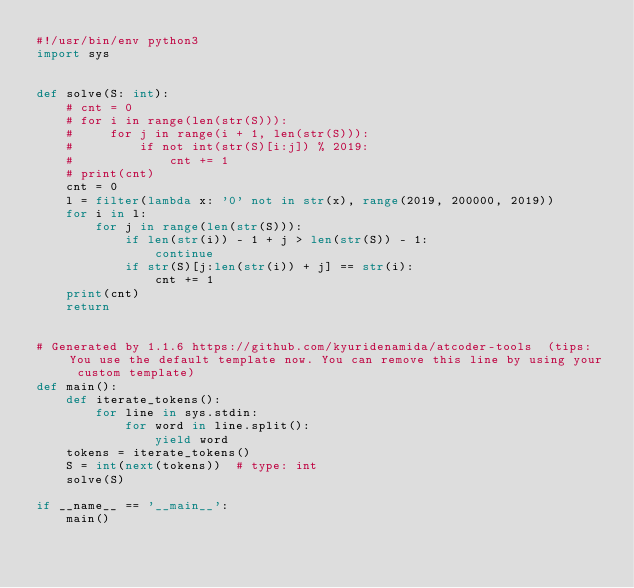Convert code to text. <code><loc_0><loc_0><loc_500><loc_500><_Python_>#!/usr/bin/env python3
import sys
 
 
def solve(S: int):
    # cnt = 0
    # for i in range(len(str(S))):
    #     for j in range(i + 1, len(str(S))):
    #         if not int(str(S)[i:j]) % 2019:
    #             cnt += 1
    # print(cnt)
    cnt = 0
    l = filter(lambda x: '0' not in str(x), range(2019, 200000, 2019))
    for i in l:
        for j in range(len(str(S))):
            if len(str(i)) - 1 + j > len(str(S)) - 1:
                continue
            if str(S)[j:len(str(i)) + j] == str(i):
                cnt += 1
    print(cnt)
    return
 
 
# Generated by 1.1.6 https://github.com/kyuridenamida/atcoder-tools  (tips: You use the default template now. You can remove this line by using your custom template)
def main():
    def iterate_tokens():
        for line in sys.stdin:
            for word in line.split():
                yield word
    tokens = iterate_tokens()
    S = int(next(tokens))  # type: int
    solve(S)
 
if __name__ == '__main__':
    main()</code> 